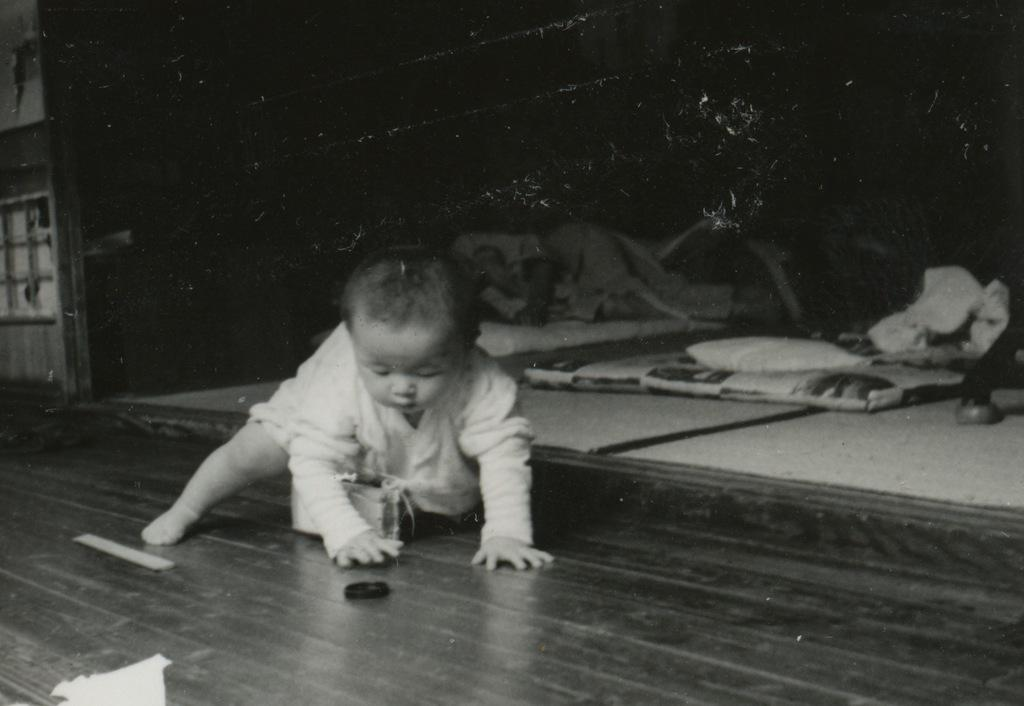What is the baby doing in the image? The baby is crawling on the floor in the image. Can you describe the background of the image? There is a person, pillows, and a wall in the background of the image. What type of amusement can be seen in the background of the image? There is no amusement present in the image; it features a baby crawling on the floor and a background with a person, pillows, and a wall. 